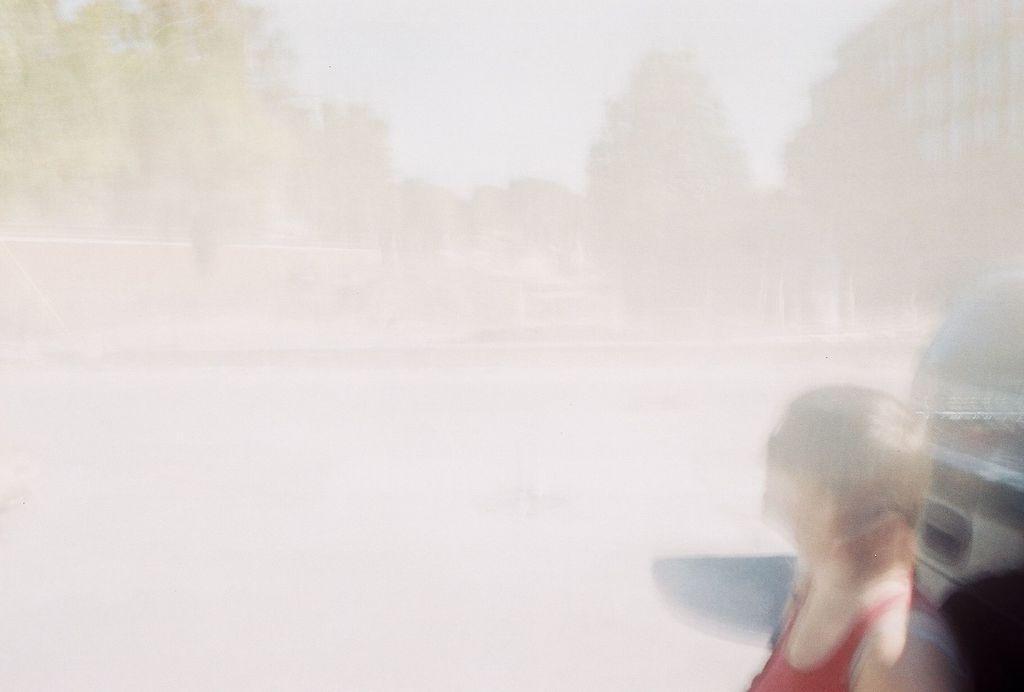Describe this image in one or two sentences. In this image we can see a person and a vehicle which is truncated. There is a blur background. We can see trees, building, and sky. 